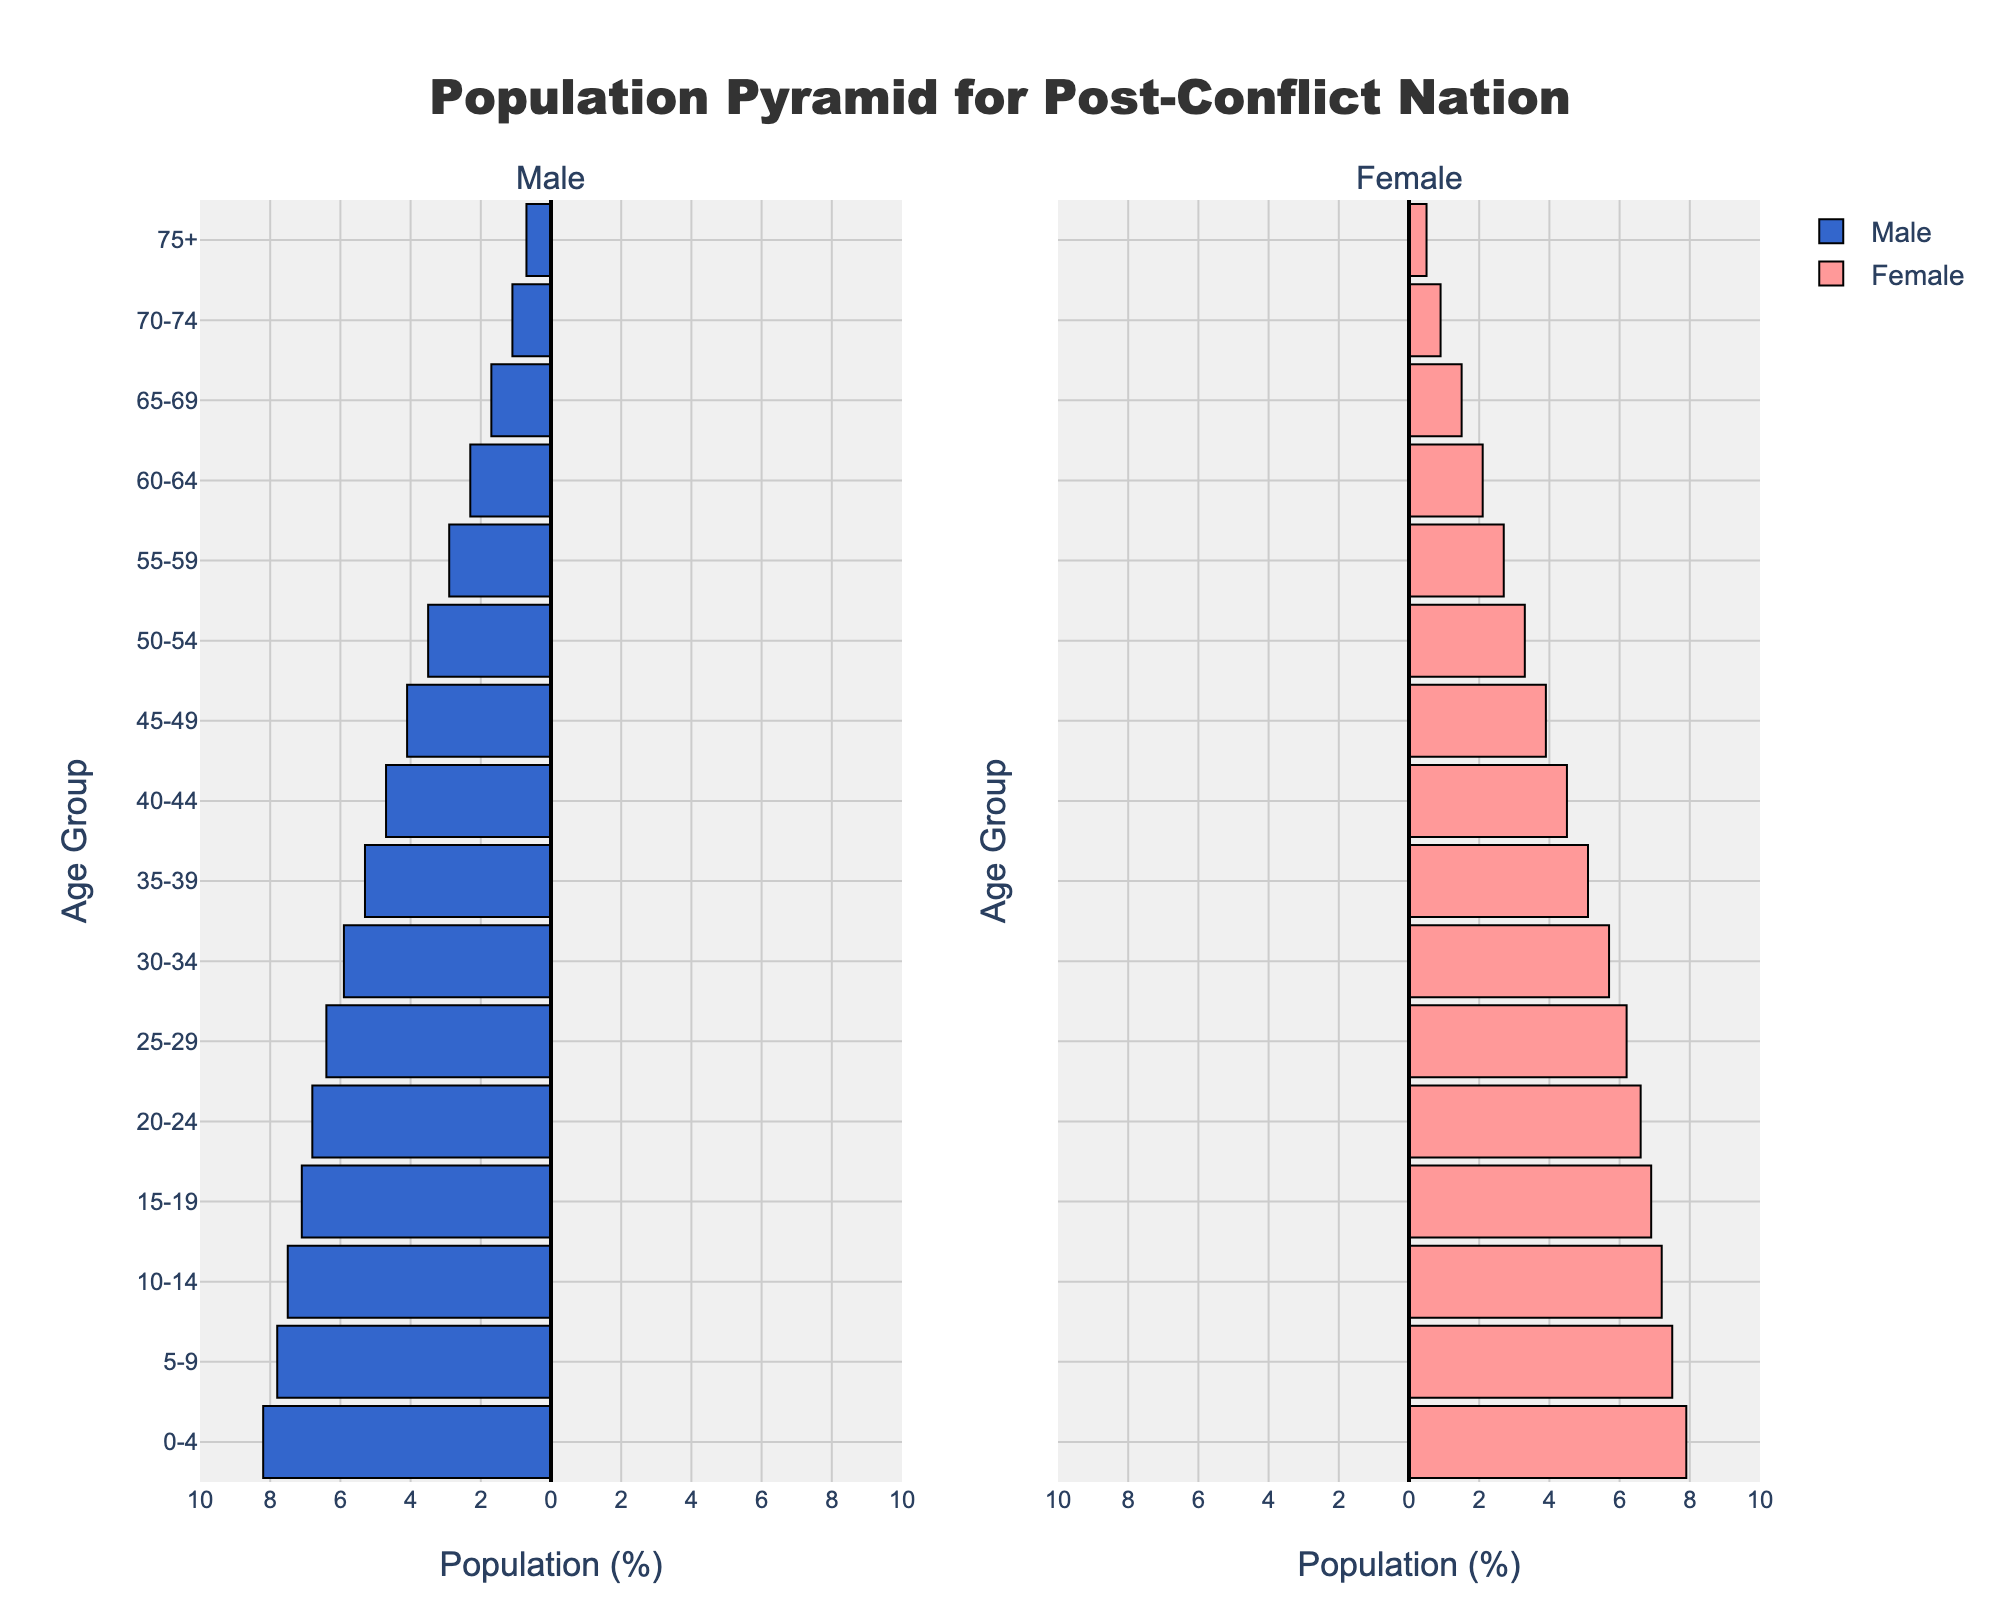Which age group has the highest percentage of males? Look at the bars representing males, particularly focusing on the lengths shown for each age group to identify which one extends the furthest to the left. The 0-4 age group bar is the longest among them.
Answer: 0-4 Which age group has the highest percentage of females? Look at the female bars to identify which is the longest. The 0-4 age group bar stands out as the longest among the female age groups.
Answer: 0-4 By how much does the population percentage of 0-4 year-old males exceed that of 15-19 year-old males? Find the length of the bars for each group: 0-4 year-olds (8.2%) and 15-19 year-olds (7.1%). Calculate the difference: 8.2% - 7.1%.
Answer: 1.1% Compare the male and female populations in the 10-14 age group. Which gender is more and by what percentage? Look at both bars for the 10-14 age group: males (7.5%) and females (7.2%). Calculate the difference: 7.5% - 7.2%.
Answer: Male, 0.3% What is the total population percentage for the age group 75+? Sum the male and female percentages for the 75+ age group: 0.7% (male) + 0.5% (female).
Answer: 1.2% Is there a consistent trend in the population percentages for both genders as the age group increases? Examine the overall shape of the bars for both genders from the bottom (youngest) to the top (oldest). Notice that the percentages generally decrease for both males and females as the age group increases.
Answer: Yes Which age group shows the smallest difference in population percentages between males and females? For each age group, calculate the absolute difference between the male and female percentages. The difference for each group is found, and the smallest one is identified. The 15-19 age group has the smallest difference:
Answer: 15-19 What is the range of population percentages for both males and females? Determine the highest and lowest percentages for both genders from the data provided. For males, the highest is 8.2% (0-4 years) and the lowest is 0.7% (75+); for females, the highest is 7.9% (0-4 years) and the lowest is 0.5% (75+). Therefore the range for males is 8.2-0.7 and for females is 7.9-0.5.
Answer: Males: 7.5%, Females: 7.4% How do the population percentages between males and females compare for the age group 45-49? Look at the lengths of the bars for this specific age group: 4.1% for males and 3.9% for females. Compare these two values to determine the difference.
Answer: Males are 0.2% higher 